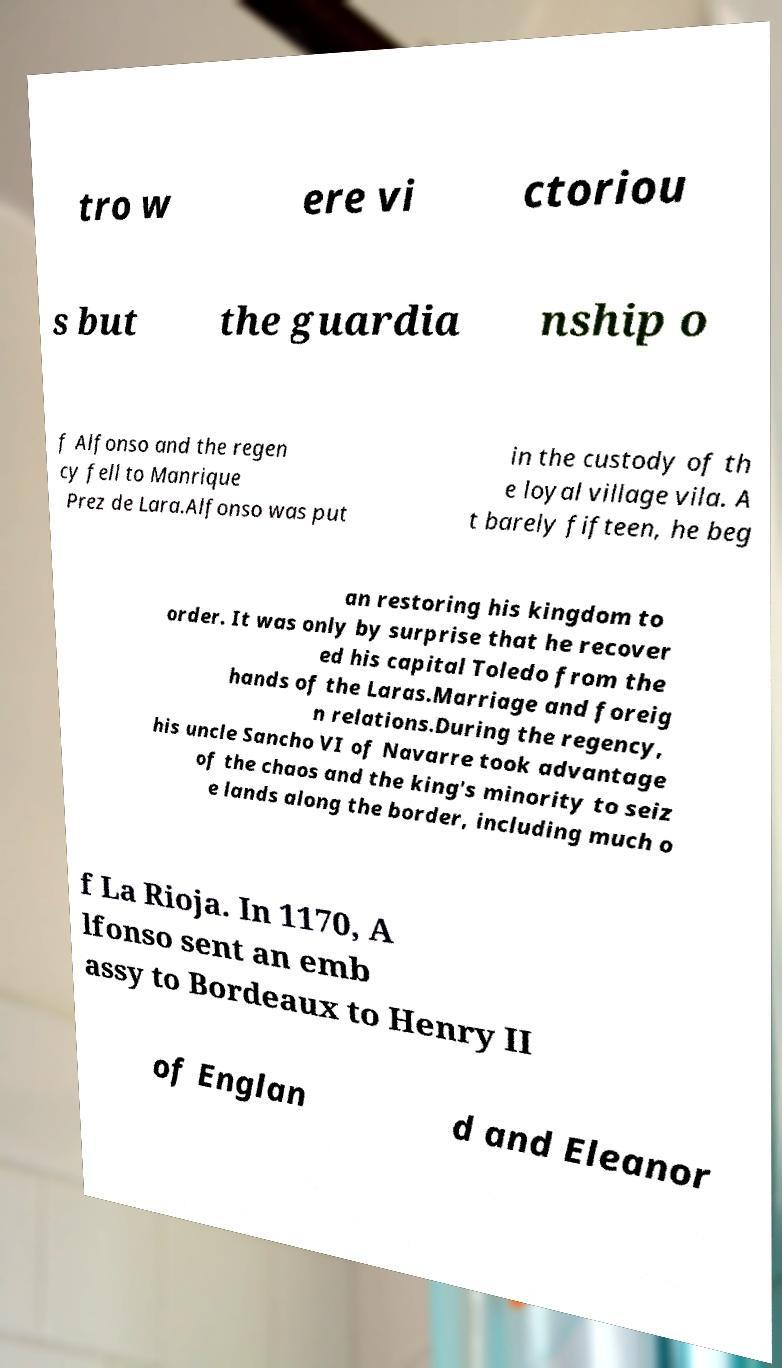For documentation purposes, I need the text within this image transcribed. Could you provide that? tro w ere vi ctoriou s but the guardia nship o f Alfonso and the regen cy fell to Manrique Prez de Lara.Alfonso was put in the custody of th e loyal village vila. A t barely fifteen, he beg an restoring his kingdom to order. It was only by surprise that he recover ed his capital Toledo from the hands of the Laras.Marriage and foreig n relations.During the regency, his uncle Sancho VI of Navarre took advantage of the chaos and the king's minority to seiz e lands along the border, including much o f La Rioja. In 1170, A lfonso sent an emb assy to Bordeaux to Henry II of Englan d and Eleanor 